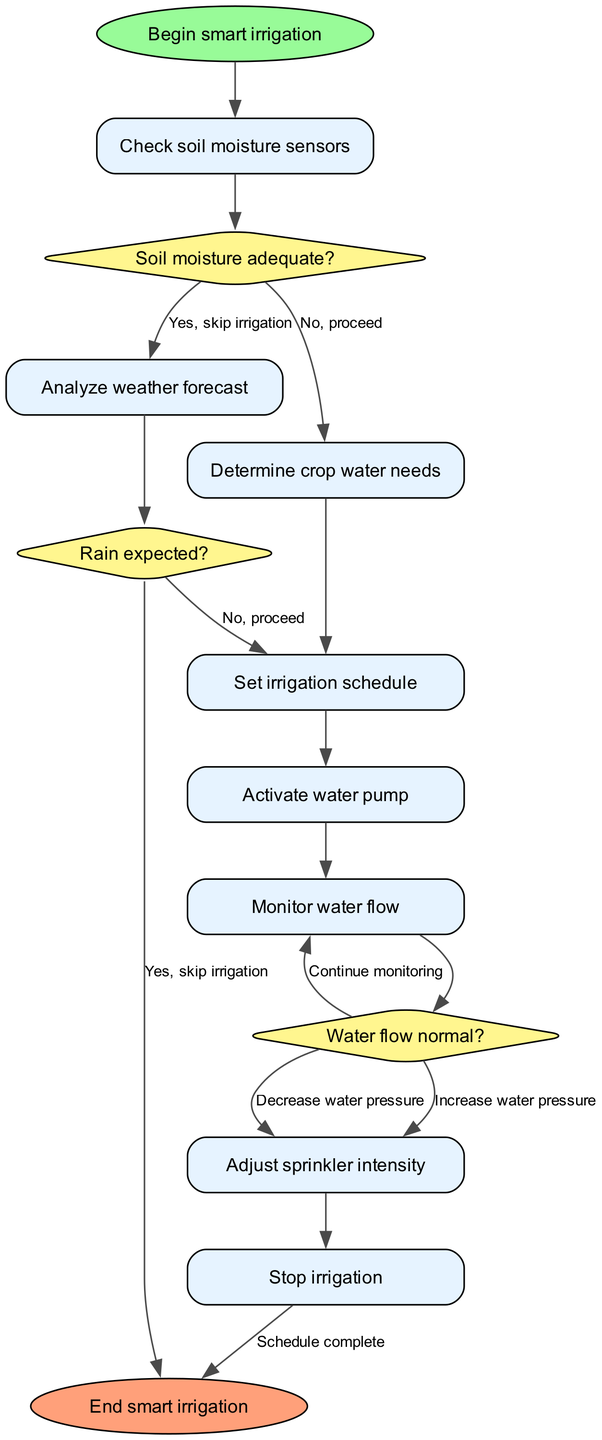What is the starting point of the diagram? The starting point of the diagram is indicated by the node labeled 'Begin smart irrigation', which is the first step in the workflow.
Answer: Begin smart irrigation How many decision nodes are there in the diagram? The diagram contains three decision nodes, which are labeled as 'Soil moisture adequate?', 'Rain expected?', and 'Water flow normal?'.
Answer: 3 What happens if soil moisture is adequate? If the soil moisture is adequate, the flowchart specifies to skip irrigation, which is indicated by the corresponding edge label from the decision node.
Answer: Skip irrigation Which node follows the analysis of the weather forecast? After analyzing the weather forecast, one proceeds to determine crop water needs, as indicated by the connection between these two nodes.
Answer: Determine crop water needs What is the last action taken before the end of the process? The last action taken before reaching the end of the process is stopping the irrigation, as denoted by the final node in the series.
Answer: Stop irrigation What occurs if rain is expected? If rain is expected, the flowchart indicates that the process ends, skipping the irrigation schedule and moving directly to the end node.
Answer: End What adjustment is made if the water flow is not normal? If the water flow is not normal, the flowchart indicates to continue monitoring the water flow, rather than making pressure adjustments or stopping irrigation.
Answer: Continue monitoring What is the purpose of the initial check in the workflow? The initial check of the soil moisture sensors determines whether irrigation is necessary based on the moisture levels detected in the soil.
Answer: To check moisture What is the final destination of the irrigation process? The final destination of the irrigation process is the node labeled 'End smart irrigation', indicating the conclusion of the workflow.
Answer: End smart irrigation 